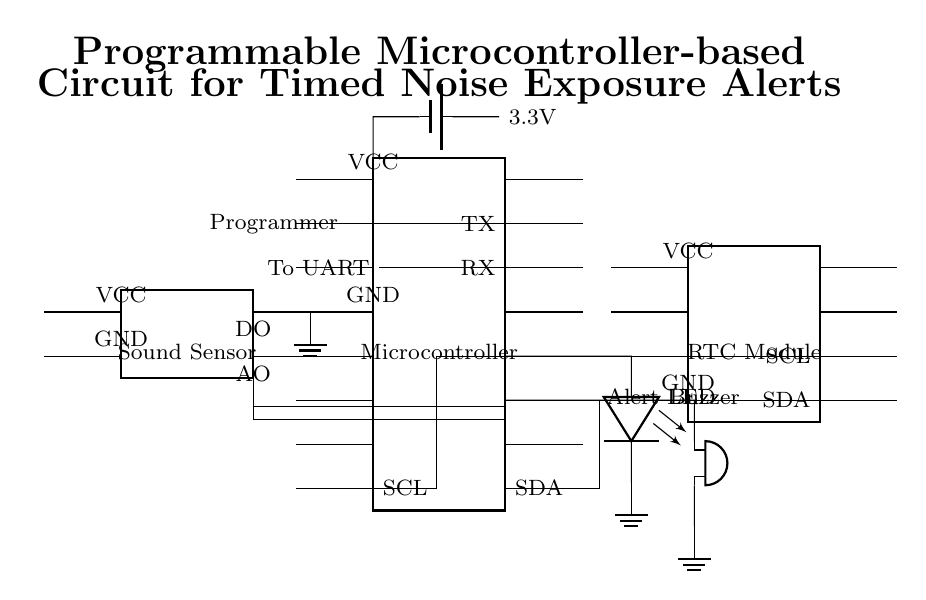What type of microcontroller is used? The circuit uses a dipchip microcontroller, which is evident from the component symbol labeled "Microcontroller" in the diagram.
Answer: Microcontroller What is the function of the RTC module? The Real-Time Clock (RTC) module is indicated in the diagram and provides time-based functions to the microcontroller, allowing it to keep track of time for timed alerts.
Answer: Timekeeping Which component indicates an alert visually? The LED is marked in the diagram as "Alert LED", which shows that it is the component responsible for visual alerts for noise exposure.
Answer: Alert LED What voltage does the power supply provide? The circuit shows a battery providing 3.3 volts, as denoted in the diagram where the battery is connected to the microcontroller's VCC pin.
Answer: 3.3 volts How are the sound sensor and microcontroller connected? The sound sensor is connected to the microcontroller via its analog output and digital output pins, as indicated by the lines showing connections from the sensor to specific pins on the microcontroller.
Answer: Analog and digital connections What action does the buzzer perform? The buzzer is connected to the microcontroller and is used for sound alerts based on the noise level detected, which is illustrated by its labeled placement in the circuit diagram.
Answer: Sound alert How is the programming done for the microcontroller? Programming is done through a UART connection, as shown by the labeled pins for RX and TX on the microcontroller, which are used for serial communication during programming.
Answer: UART connection 